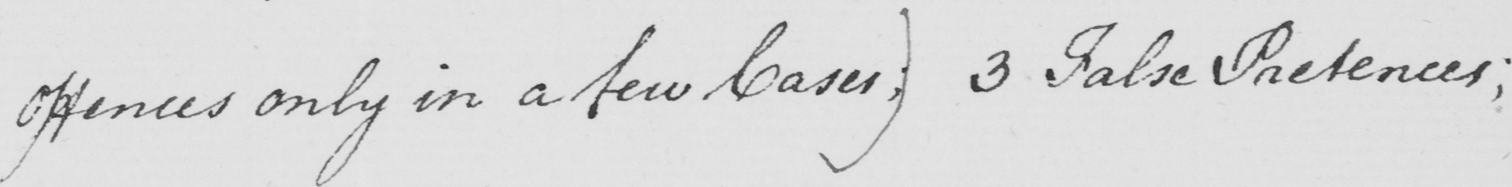What does this handwritten line say? Offences only in a few Cases; )  3 False Pretences ; 